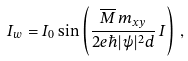Convert formula to latex. <formula><loc_0><loc_0><loc_500><loc_500>I _ { w } = I _ { 0 } \sin \left ( \frac { { \overline { M } \, m _ { x y } } } { 2 e \hbar { | } \psi | ^ { 2 } d } \, I \right ) \, ,</formula> 